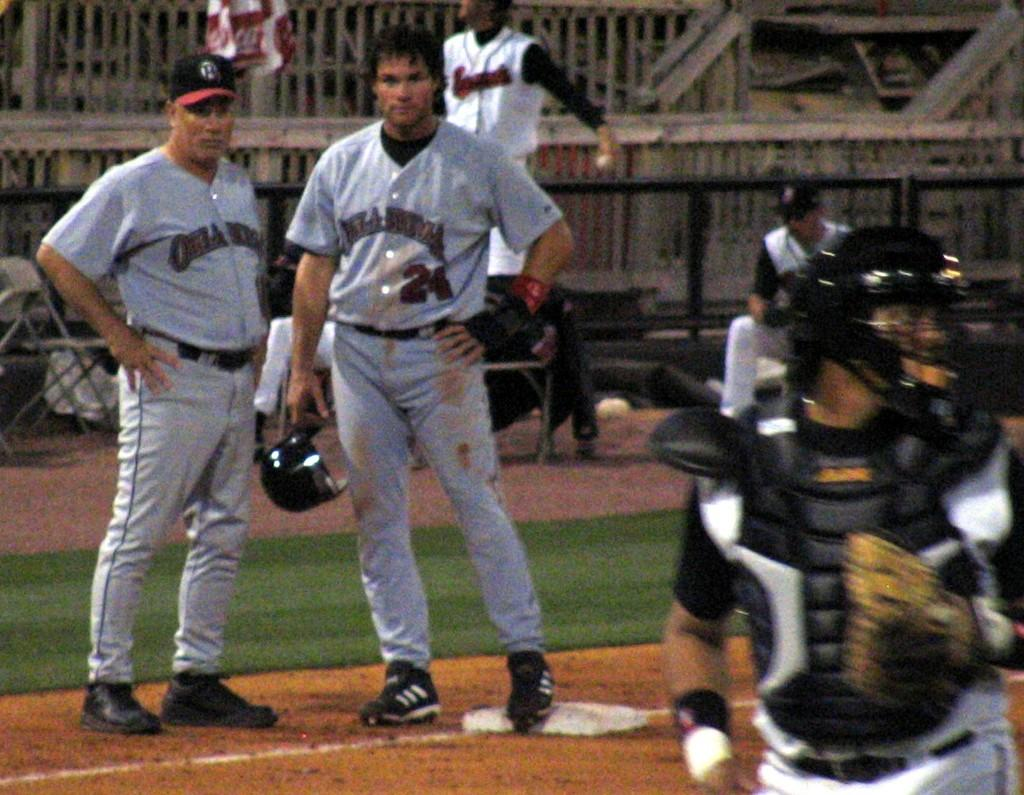Provide a one-sentence caption for the provided image. Two pro ball players in Oklahoma uniforms confer mid-game. 